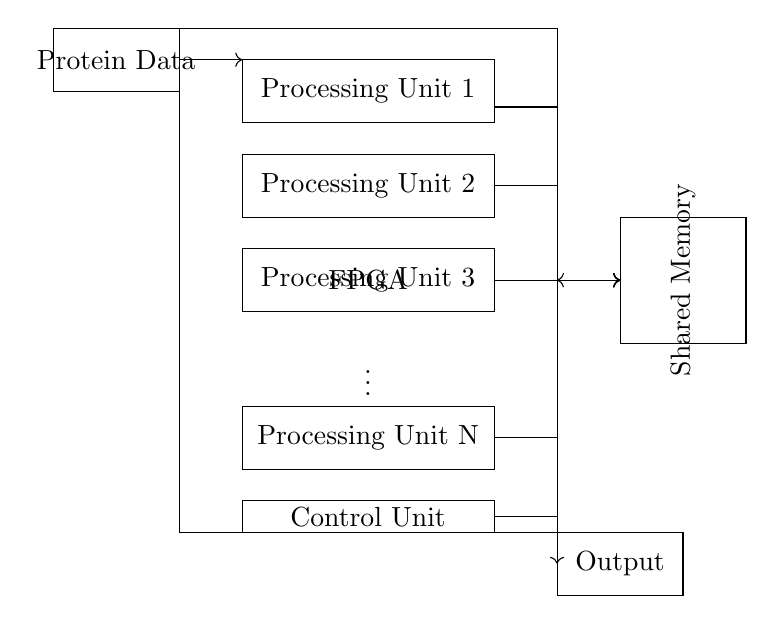What is the main component shown in this circuit? The main component is the FPGA, which is the central unit responsible for processing the protein data. It is highlighted prominently within the diagram.
Answer: FPGA How many processing units are depicted in the diagram? The diagram illustrates N processing units, where N is indicated as the last unit shown. The number of units can be deduced from the standard representation of the processing units in the circuit.
Answer: N What is the function of the shared memory in this circuit? The shared memory allows different processing units to access and store the protein data during simulations, facilitating coordination between the parallel processing units.
Answer: Coordination What does the control unit manage in this circuit? The control unit is responsible for orchestrating the operations of the different processing units and managing the flow of data within the FPGA. This ensures that the protein folding simulations are processed efficiently.
Answer: Orchestration What type of data does the input section receive? The input section receives protein data, which is essential for initiating the protein folding simulations managed by the processing units.
Answer: Protein Data 